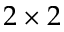<formula> <loc_0><loc_0><loc_500><loc_500>2 \times 2</formula> 